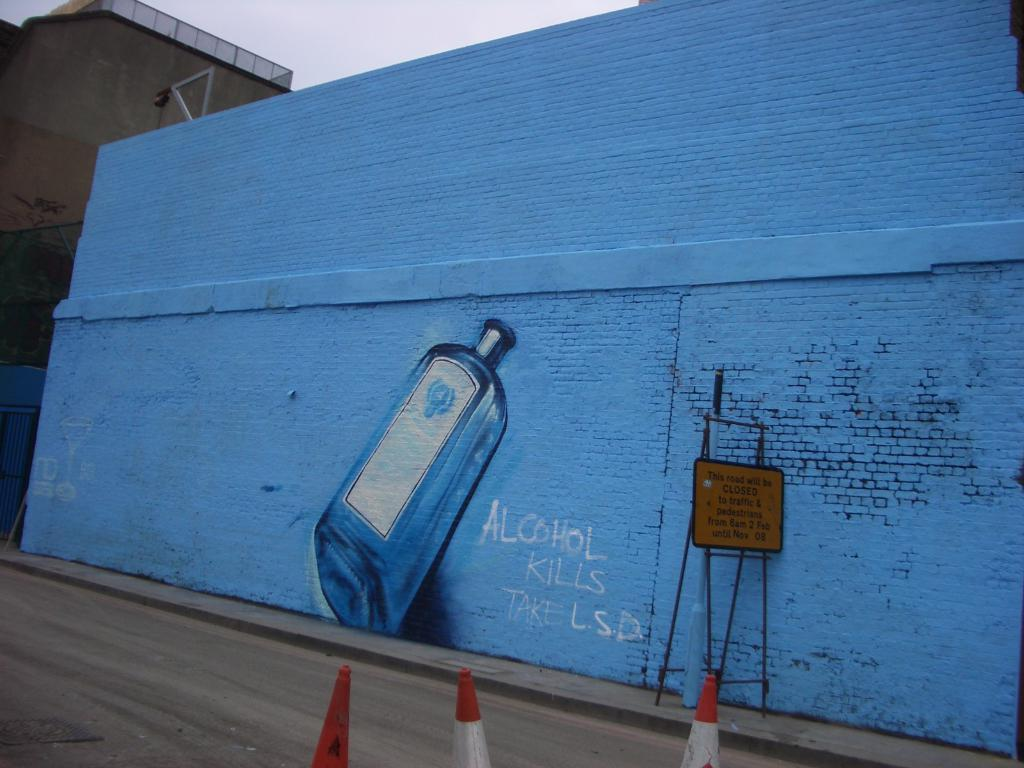<image>
Summarize the visual content of the image. A wall mural of an alcohol bottle has graffiti encouraging L.S.D use. 